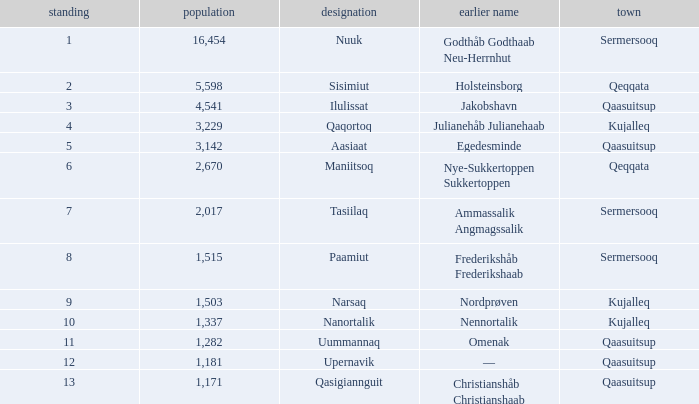What is the population for Rank 11? 1282.0. 